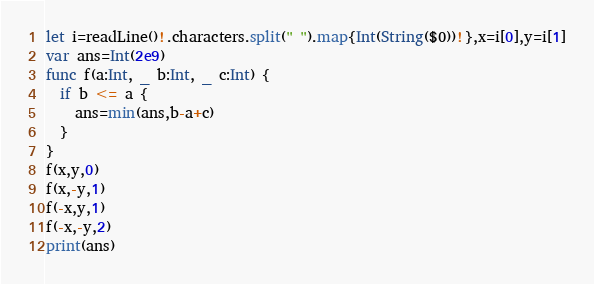Convert code to text. <code><loc_0><loc_0><loc_500><loc_500><_Swift_>let i=readLine()!.characters.split(" ").map{Int(String($0))!},x=i[0],y=i[1]
var ans=Int(2e9)
func f(a:Int, _ b:Int, _ c:Int) {
  if b <= a {
    ans=min(ans,b-a+c)
  }
}
f(x,y,0)
f(x,-y,1)
f(-x,y,1)
f(-x,-y,2)
print(ans)</code> 